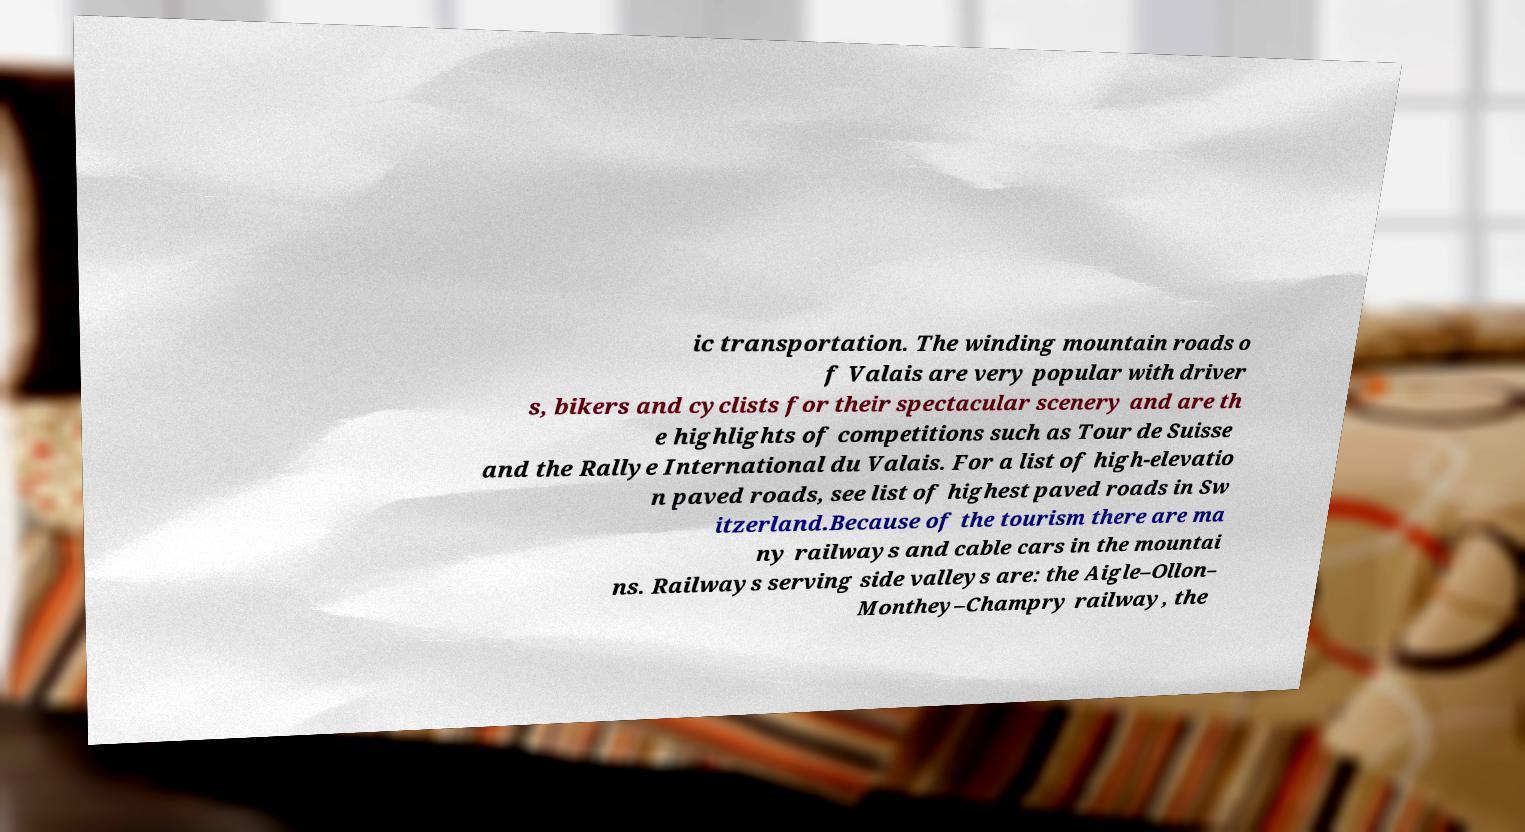For documentation purposes, I need the text within this image transcribed. Could you provide that? ic transportation. The winding mountain roads o f Valais are very popular with driver s, bikers and cyclists for their spectacular scenery and are th e highlights of competitions such as Tour de Suisse and the Rallye International du Valais. For a list of high-elevatio n paved roads, see list of highest paved roads in Sw itzerland.Because of the tourism there are ma ny railways and cable cars in the mountai ns. Railways serving side valleys are: the Aigle–Ollon– Monthey–Champry railway, the 